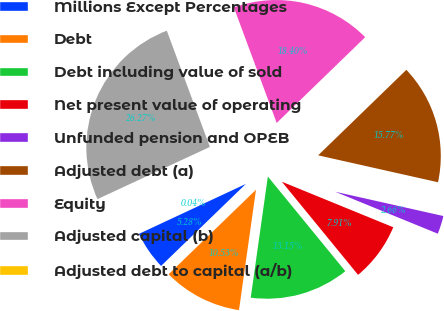Convert chart. <chart><loc_0><loc_0><loc_500><loc_500><pie_chart><fcel>Millions Except Percentages<fcel>Debt<fcel>Debt including value of sold<fcel>Net present value of operating<fcel>Unfunded pension and OPEB<fcel>Adjusted debt (a)<fcel>Equity<fcel>Adjusted capital (b)<fcel>Adjusted debt to capital (a/b)<nl><fcel>5.28%<fcel>10.53%<fcel>13.15%<fcel>7.91%<fcel>2.66%<fcel>15.77%<fcel>18.4%<fcel>26.27%<fcel>0.04%<nl></chart> 